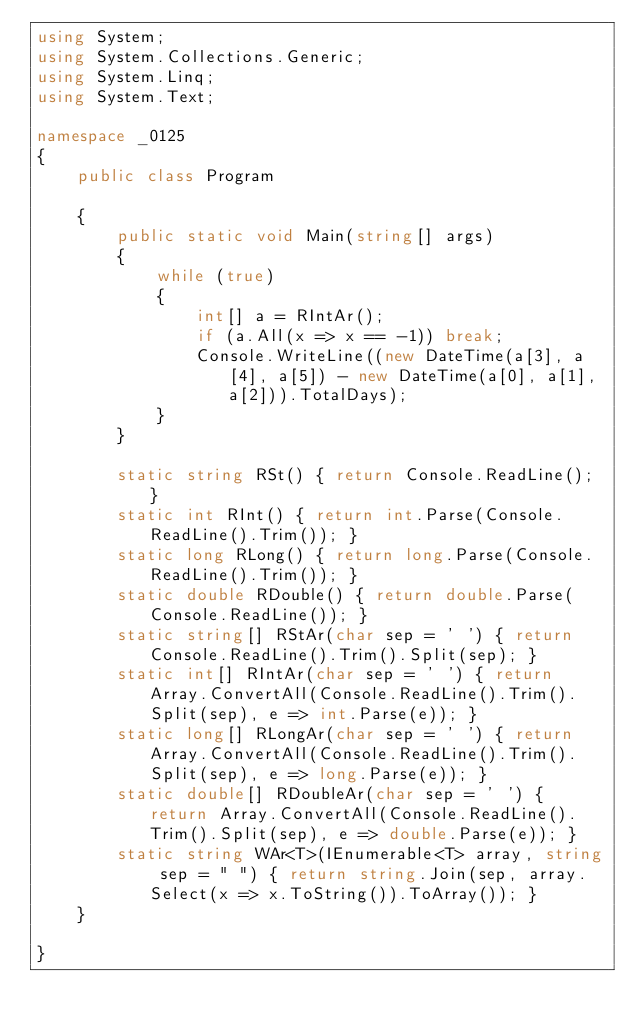Convert code to text. <code><loc_0><loc_0><loc_500><loc_500><_C#_>using System;
using System.Collections.Generic;
using System.Linq;
using System.Text;

namespace _0125
{
    public class Program

    {
        public static void Main(string[] args)
        {
            while (true)
            {
                int[] a = RIntAr();
                if (a.All(x => x == -1)) break;
                Console.WriteLine((new DateTime(a[3], a[4], a[5]) - new DateTime(a[0], a[1], a[2])).TotalDays);
            }           
        }

        static string RSt() { return Console.ReadLine(); }
        static int RInt() { return int.Parse(Console.ReadLine().Trim()); }
        static long RLong() { return long.Parse(Console.ReadLine().Trim()); }
        static double RDouble() { return double.Parse(Console.ReadLine()); }
        static string[] RStAr(char sep = ' ') { return Console.ReadLine().Trim().Split(sep); }
        static int[] RIntAr(char sep = ' ') { return Array.ConvertAll(Console.ReadLine().Trim().Split(sep), e => int.Parse(e)); }
        static long[] RLongAr(char sep = ' ') { return Array.ConvertAll(Console.ReadLine().Trim().Split(sep), e => long.Parse(e)); }
        static double[] RDoubleAr(char sep = ' ') { return Array.ConvertAll(Console.ReadLine().Trim().Split(sep), e => double.Parse(e)); }
        static string WAr<T>(IEnumerable<T> array, string sep = " ") { return string.Join(sep, array.Select(x => x.ToString()).ToArray()); }
    }

}

</code> 